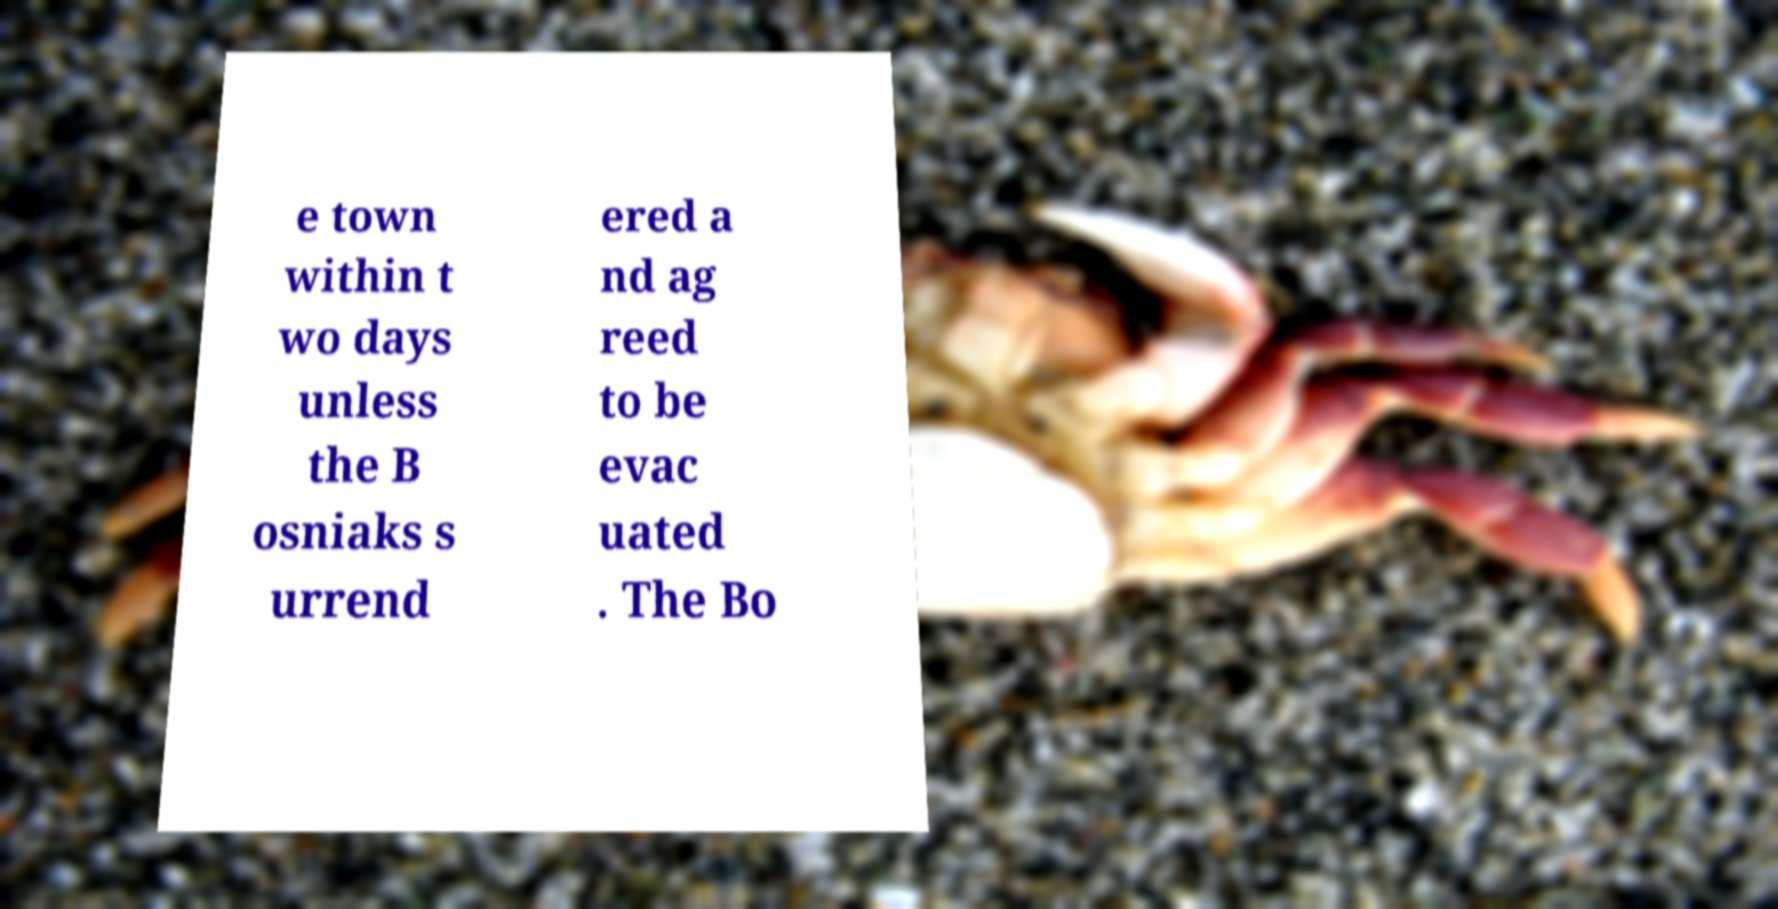For documentation purposes, I need the text within this image transcribed. Could you provide that? e town within t wo days unless the B osniaks s urrend ered a nd ag reed to be evac uated . The Bo 